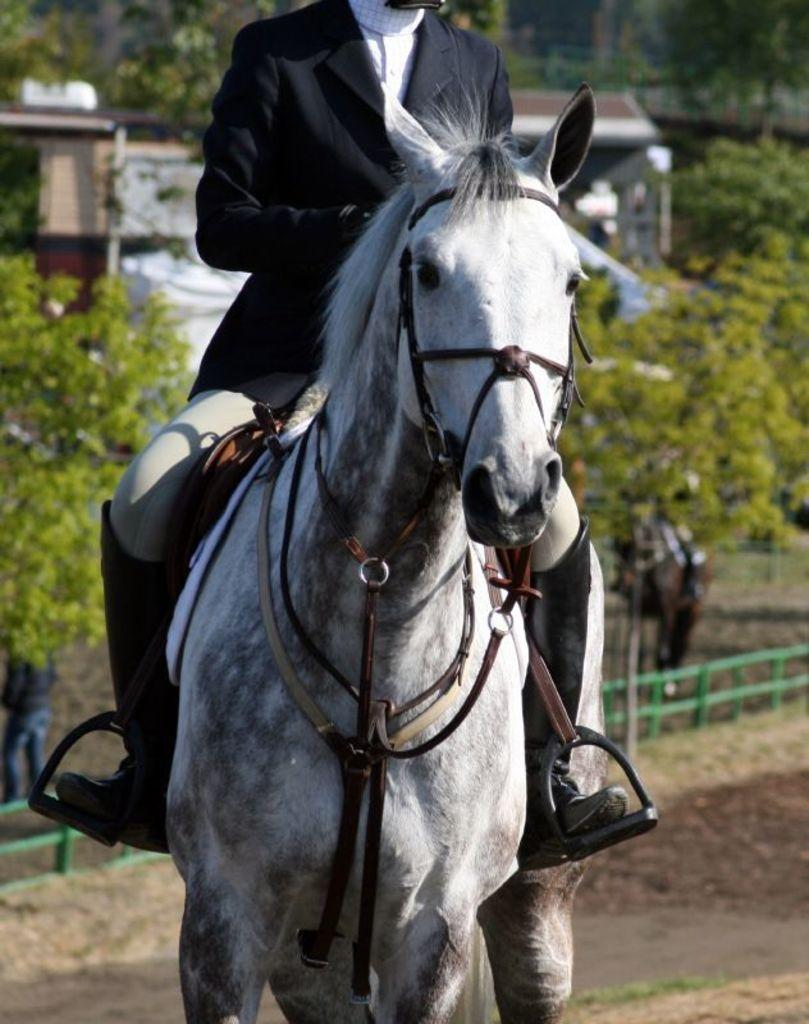What is the main subject of the image? There is a person in the image. What is the person doing in the image? The person is riding a horse. What type of environment can be seen in the image? There are trees in the image, which suggests a natural setting. Where might this image have been taken? The image appears to be taken at a roadside. What type of water can be seen in the image? There is no water visible in the image. What is the aftermath of the person's ride in the image? The image does not show any aftermath of the person's ride, as it captures the moment when they are still riding the horse. 